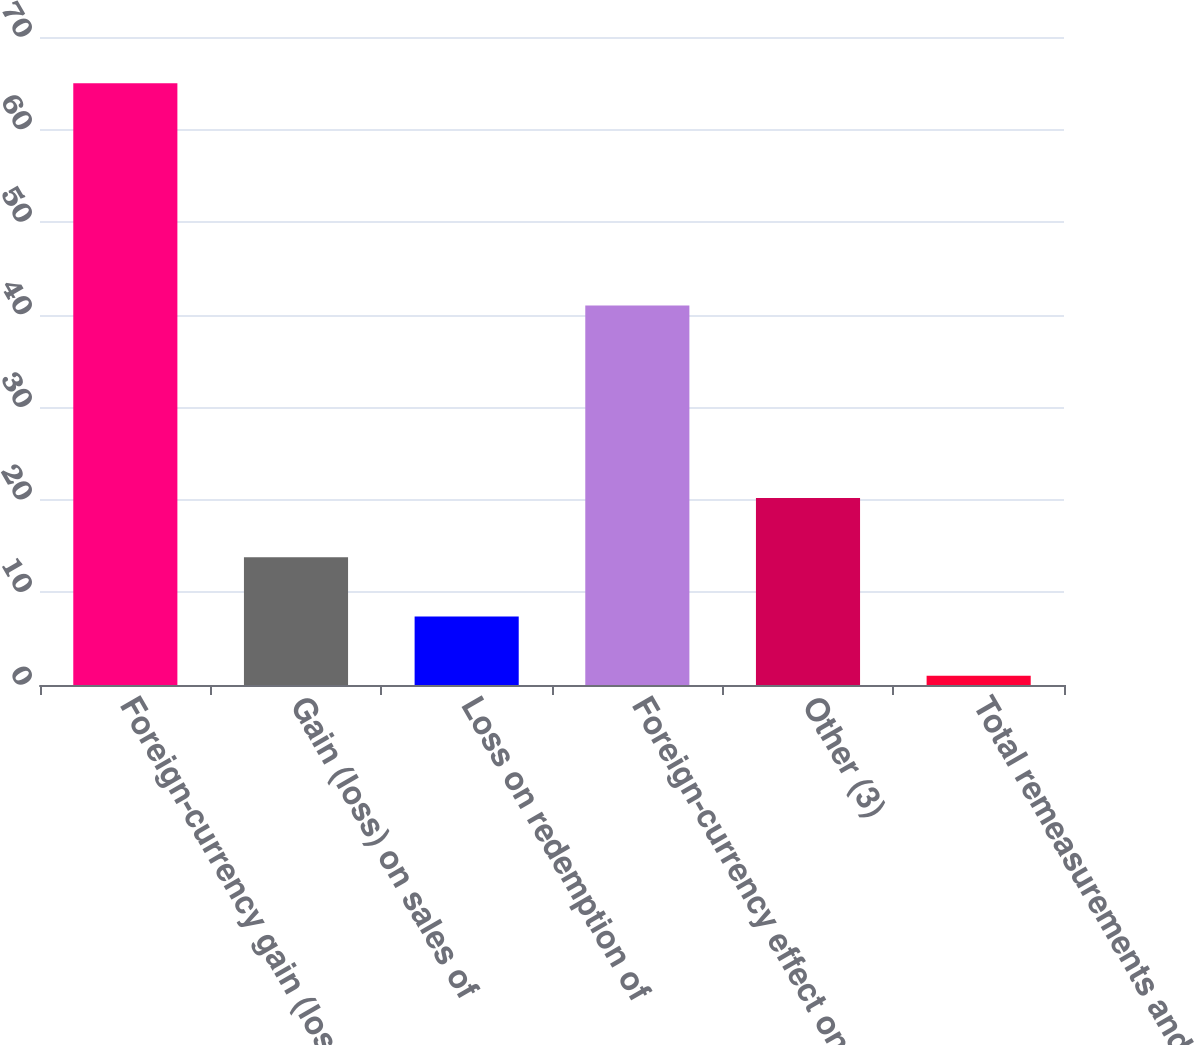Convert chart to OTSL. <chart><loc_0><loc_0><loc_500><loc_500><bar_chart><fcel>Foreign-currency gain (loss)<fcel>Gain (loss) on sales of<fcel>Loss on redemption of<fcel>Foreign-currency effect on<fcel>Other (3)<fcel>Total remeasurements and other<nl><fcel>65<fcel>13.8<fcel>7.4<fcel>41<fcel>20.2<fcel>1<nl></chart> 